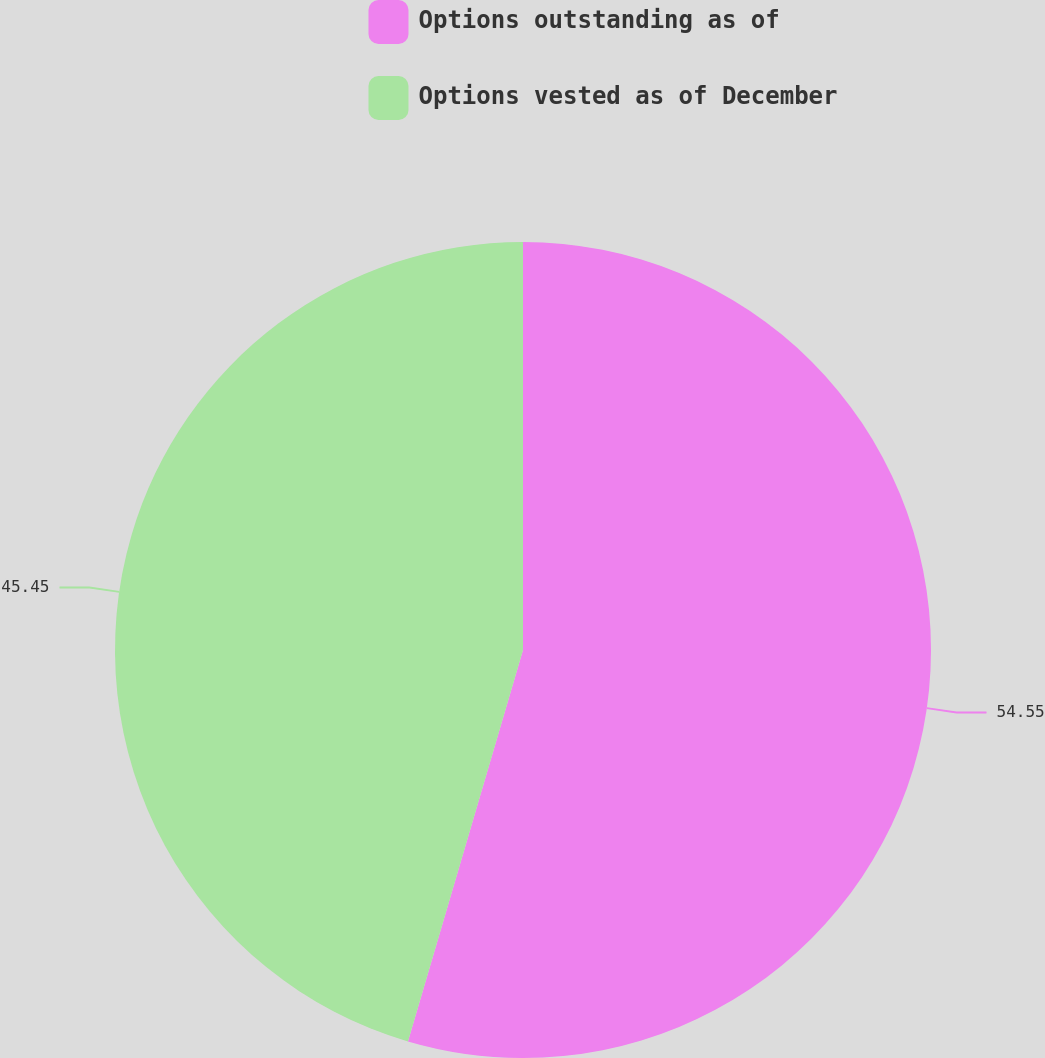Convert chart to OTSL. <chart><loc_0><loc_0><loc_500><loc_500><pie_chart><fcel>Options outstanding as of<fcel>Options vested as of December<nl><fcel>54.55%<fcel>45.45%<nl></chart> 